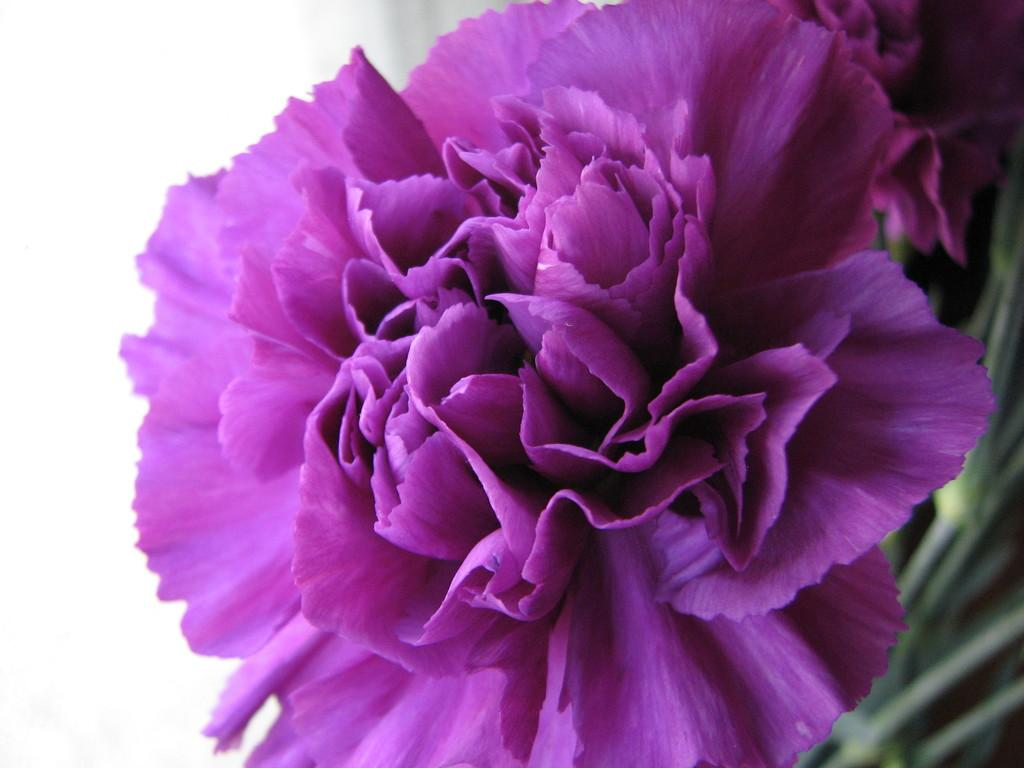What is the main subject of the image? There is a flower in the image. Can you describe the color of the flower? The flower is purple in color. in color. What type of trade agreement is being discussed in the image? There is no indication of any trade agreement or discussion in the image; it features a single flower. What kind of wire is used to support the flower in the image? There is no wire present in the image; the flower is not supported by any visible structure. 